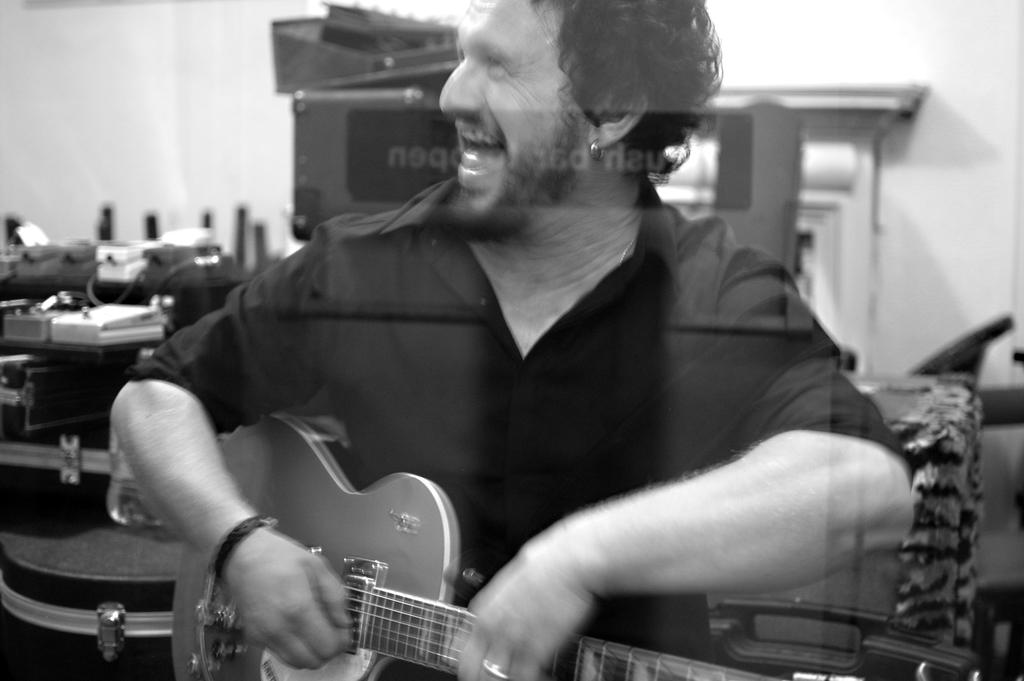What is the main subject of the image? The main subject of the image is a man. What is the man holding in his hand? The man is holding a guitar in his hand. What type of flowers can be seen growing around the man in the image? There are no flowers present in the image; it only features a man holding a guitar. 